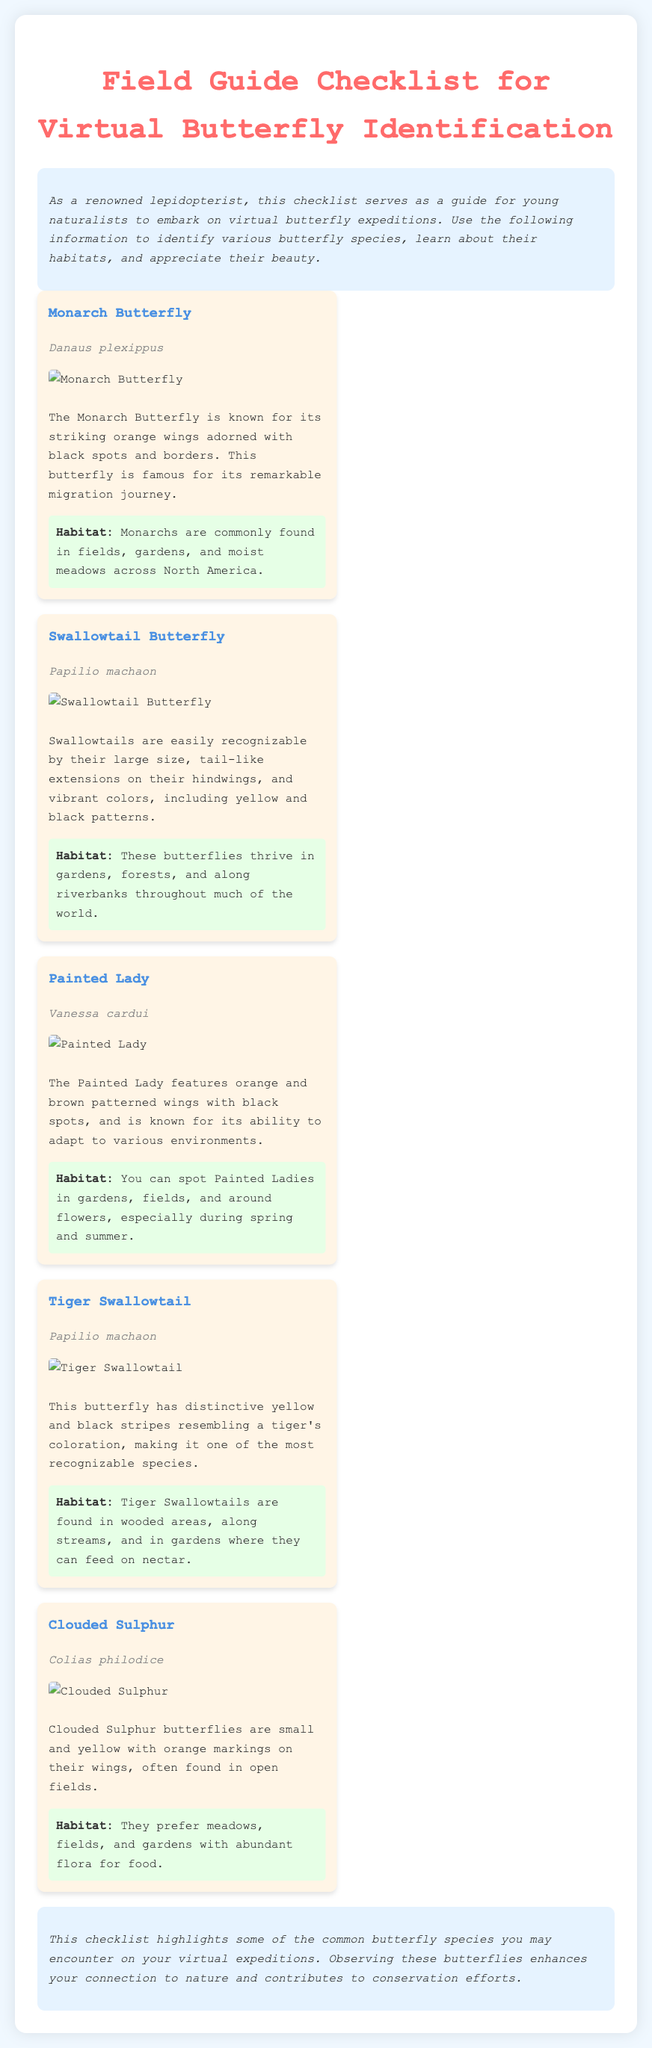What is the title of the document? The title, displayed prominently at the top, indicates the subject of the document.
Answer: Field Guide Checklist for Virtual Butterfly Identification Who is the scientific name of the Monarch Butterfly? The scientific name is listed directly under the common name for each butterfly.
Answer: Danaus plexippus What color are the wings of the Clouded Sulphur? The description states the color of the Clouded Sulphur's wings in the context of their appearance.
Answer: Yellow Which butterfly is known for its migration journey? The document specifically mentions this characteristic in the description for the butterfly.
Answer: Monarch Butterfly In which habitat are Painted Ladies typically found? The document lists specific habitats for each butterfly; looking for Painted Lady's habitat gives the answer.
Answer: Gardens, fields, around flowers How many butterflies are described in the checklist? Counting the individual butterfly sections gives the total number mentioned in the document.
Answer: Five Which butterfly has tail-like extensions on their hindwings? This characteristic is uniquely described in the section for one of the butterflies.
Answer: Swallowtail Butterfly What is the primary color of the Tiger Swallowtail? The description of the Tiger Swallowtail mentions its colors that are indicative of its appearance.
Answer: Yellow and black 